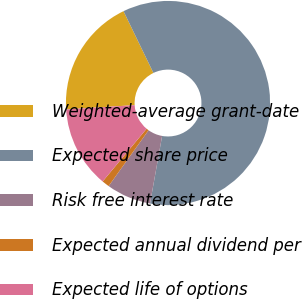Convert chart to OTSL. <chart><loc_0><loc_0><loc_500><loc_500><pie_chart><fcel>Weighted-average grant-date<fcel>Expected share price<fcel>Risk free interest rate<fcel>Expected annual dividend per<fcel>Expected life of options<nl><fcel>18.82%<fcel>60.0%<fcel>7.06%<fcel>1.18%<fcel>12.94%<nl></chart> 